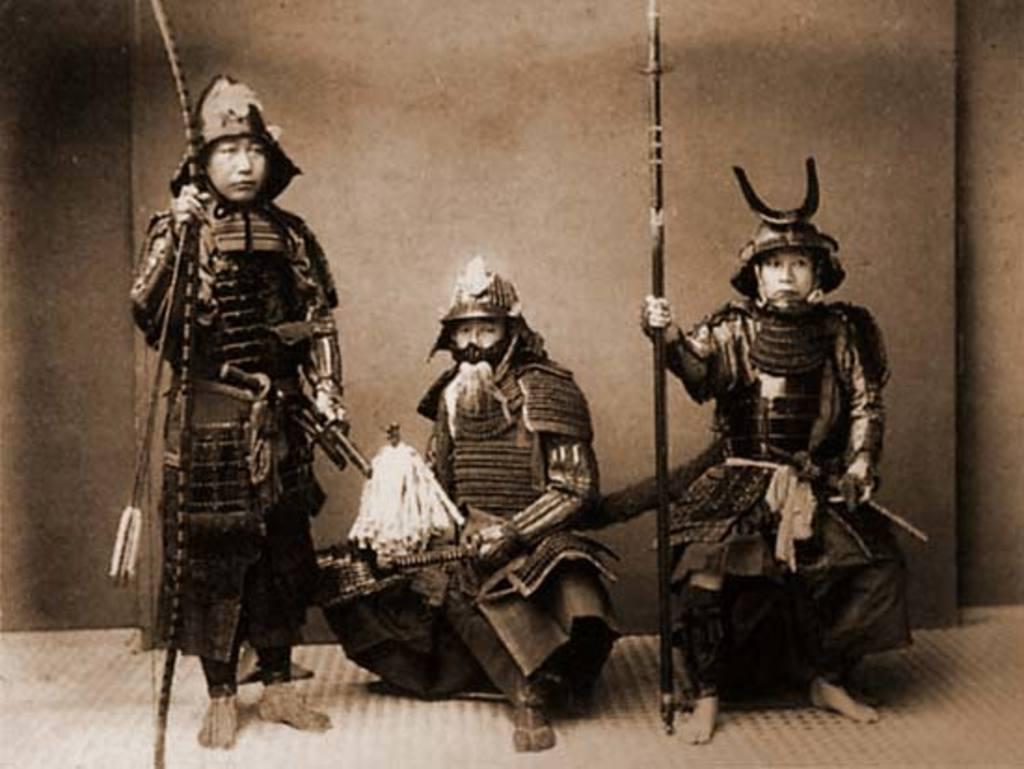Could you give a brief overview of what you see in this image? In this image we can see group of people standing on the floor. One person is holding a stick in his hand. One person holding a knife in his hand. 